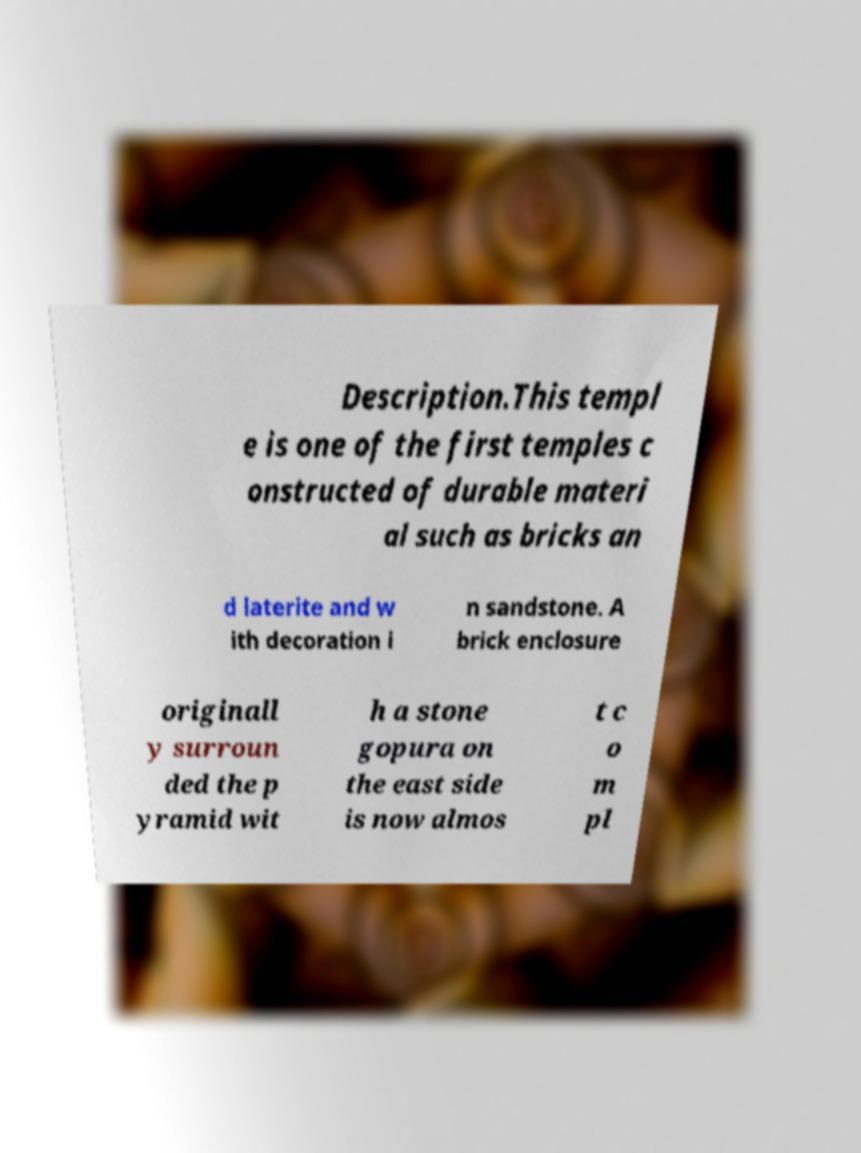Could you extract and type out the text from this image? Description.This templ e is one of the first temples c onstructed of durable materi al such as bricks an d laterite and w ith decoration i n sandstone. A brick enclosure originall y surroun ded the p yramid wit h a stone gopura on the east side is now almos t c o m pl 